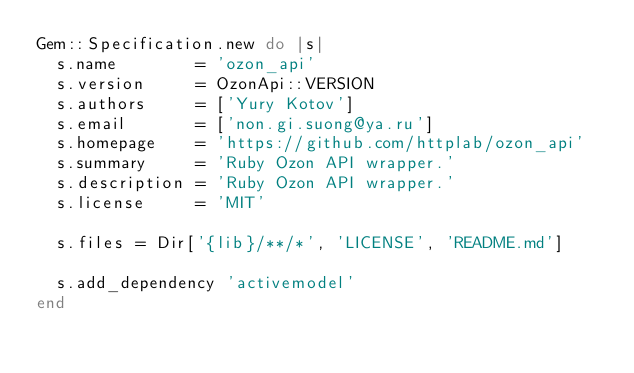Convert code to text. <code><loc_0><loc_0><loc_500><loc_500><_Ruby_>Gem::Specification.new do |s|
  s.name        = 'ozon_api'
  s.version     = OzonApi::VERSION
  s.authors     = ['Yury Kotov']
  s.email       = ['non.gi.suong@ya.ru']
  s.homepage    = 'https://github.com/httplab/ozon_api'
  s.summary     = 'Ruby Ozon API wrapper.'
  s.description = 'Ruby Ozon API wrapper.'
  s.license     = 'MIT'

  s.files = Dir['{lib}/**/*', 'LICENSE', 'README.md']

  s.add_dependency 'activemodel'
end
</code> 